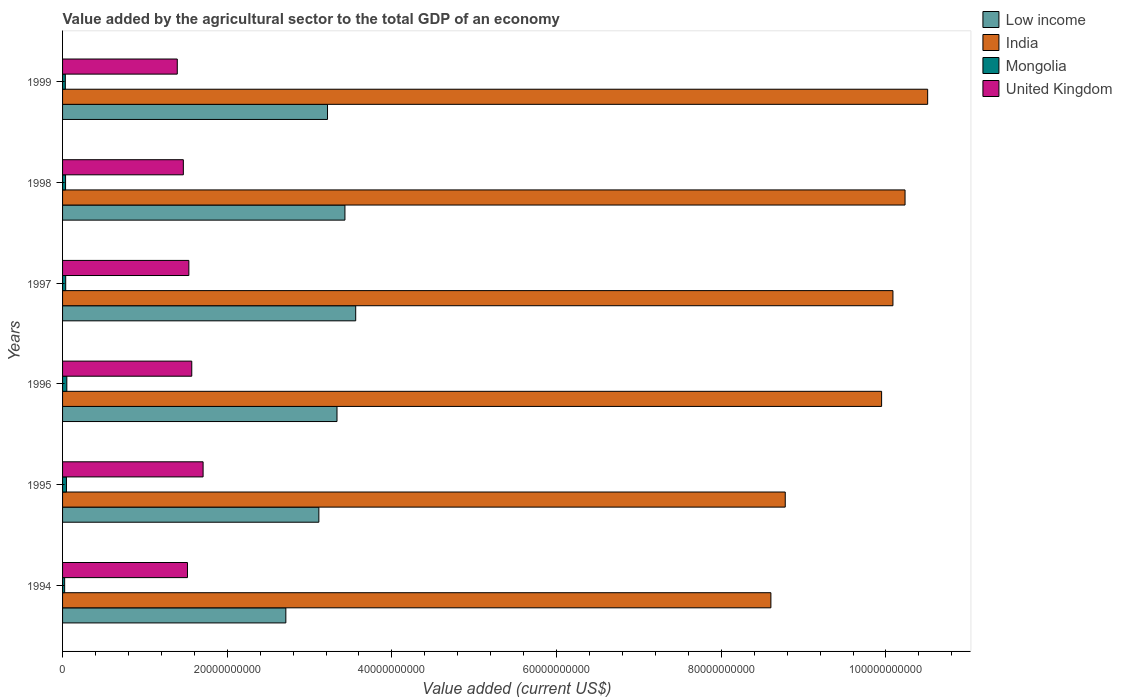How many groups of bars are there?
Your response must be concise. 6. Are the number of bars per tick equal to the number of legend labels?
Your response must be concise. Yes. Are the number of bars on each tick of the Y-axis equal?
Provide a short and direct response. Yes. How many bars are there on the 6th tick from the bottom?
Give a very brief answer. 4. In how many cases, is the number of bars for a given year not equal to the number of legend labels?
Offer a very short reply. 0. What is the value added by the agricultural sector to the total GDP in Low income in 1998?
Ensure brevity in your answer.  3.43e+1. Across all years, what is the maximum value added by the agricultural sector to the total GDP in India?
Make the answer very short. 1.05e+11. Across all years, what is the minimum value added by the agricultural sector to the total GDP in United Kingdom?
Provide a succinct answer. 1.39e+1. In which year was the value added by the agricultural sector to the total GDP in Low income maximum?
Keep it short and to the point. 1997. In which year was the value added by the agricultural sector to the total GDP in United Kingdom minimum?
Offer a terse response. 1999. What is the total value added by the agricultural sector to the total GDP in United Kingdom in the graph?
Provide a succinct answer. 9.19e+1. What is the difference between the value added by the agricultural sector to the total GDP in United Kingdom in 1995 and that in 1999?
Give a very brief answer. 3.13e+09. What is the difference between the value added by the agricultural sector to the total GDP in Mongolia in 1994 and the value added by the agricultural sector to the total GDP in United Kingdom in 1999?
Provide a short and direct response. -1.37e+1. What is the average value added by the agricultural sector to the total GDP in United Kingdom per year?
Make the answer very short. 1.53e+1. In the year 1999, what is the difference between the value added by the agricultural sector to the total GDP in Low income and value added by the agricultural sector to the total GDP in Mongolia?
Your answer should be very brief. 3.18e+1. In how many years, is the value added by the agricultural sector to the total GDP in Low income greater than 40000000000 US$?
Give a very brief answer. 0. What is the ratio of the value added by the agricultural sector to the total GDP in United Kingdom in 1998 to that in 1999?
Make the answer very short. 1.05. Is the difference between the value added by the agricultural sector to the total GDP in Low income in 1995 and 1996 greater than the difference between the value added by the agricultural sector to the total GDP in Mongolia in 1995 and 1996?
Keep it short and to the point. No. What is the difference between the highest and the second highest value added by the agricultural sector to the total GDP in Low income?
Offer a very short reply. 1.31e+09. What is the difference between the highest and the lowest value added by the agricultural sector to the total GDP in Mongolia?
Keep it short and to the point. 2.63e+08. In how many years, is the value added by the agricultural sector to the total GDP in United Kingdom greater than the average value added by the agricultural sector to the total GDP in United Kingdom taken over all years?
Provide a short and direct response. 3. Is the sum of the value added by the agricultural sector to the total GDP in Mongolia in 1994 and 1996 greater than the maximum value added by the agricultural sector to the total GDP in India across all years?
Your answer should be very brief. No. Is it the case that in every year, the sum of the value added by the agricultural sector to the total GDP in Mongolia and value added by the agricultural sector to the total GDP in Low income is greater than the sum of value added by the agricultural sector to the total GDP in India and value added by the agricultural sector to the total GDP in United Kingdom?
Your answer should be compact. Yes. Are all the bars in the graph horizontal?
Offer a terse response. Yes. How many years are there in the graph?
Your answer should be very brief. 6. Are the values on the major ticks of X-axis written in scientific E-notation?
Keep it short and to the point. No. Does the graph contain grids?
Your answer should be compact. No. What is the title of the graph?
Your answer should be very brief. Value added by the agricultural sector to the total GDP of an economy. What is the label or title of the X-axis?
Keep it short and to the point. Value added (current US$). What is the Value added (current US$) in Low income in 1994?
Your response must be concise. 2.71e+1. What is the Value added (current US$) in India in 1994?
Your answer should be compact. 8.60e+1. What is the Value added (current US$) in Mongolia in 1994?
Make the answer very short. 2.54e+08. What is the Value added (current US$) of United Kingdom in 1994?
Your answer should be compact. 1.52e+1. What is the Value added (current US$) of Low income in 1995?
Ensure brevity in your answer.  3.11e+1. What is the Value added (current US$) of India in 1995?
Offer a very short reply. 8.78e+1. What is the Value added (current US$) of Mongolia in 1995?
Ensure brevity in your answer.  4.73e+08. What is the Value added (current US$) of United Kingdom in 1995?
Keep it short and to the point. 1.71e+1. What is the Value added (current US$) of Low income in 1996?
Keep it short and to the point. 3.33e+1. What is the Value added (current US$) of India in 1996?
Offer a terse response. 9.95e+1. What is the Value added (current US$) of Mongolia in 1996?
Give a very brief answer. 5.18e+08. What is the Value added (current US$) in United Kingdom in 1996?
Keep it short and to the point. 1.57e+1. What is the Value added (current US$) in Low income in 1997?
Offer a very short reply. 3.56e+1. What is the Value added (current US$) of India in 1997?
Provide a short and direct response. 1.01e+11. What is the Value added (current US$) in Mongolia in 1997?
Offer a terse response. 3.81e+08. What is the Value added (current US$) of United Kingdom in 1997?
Provide a succinct answer. 1.53e+1. What is the Value added (current US$) of Low income in 1998?
Provide a short and direct response. 3.43e+1. What is the Value added (current US$) in India in 1998?
Give a very brief answer. 1.02e+11. What is the Value added (current US$) of Mongolia in 1998?
Keep it short and to the point. 3.65e+08. What is the Value added (current US$) in United Kingdom in 1998?
Keep it short and to the point. 1.47e+1. What is the Value added (current US$) in Low income in 1999?
Your response must be concise. 3.22e+1. What is the Value added (current US$) of India in 1999?
Provide a succinct answer. 1.05e+11. What is the Value added (current US$) in Mongolia in 1999?
Keep it short and to the point. 3.35e+08. What is the Value added (current US$) of United Kingdom in 1999?
Provide a short and direct response. 1.39e+1. Across all years, what is the maximum Value added (current US$) of Low income?
Ensure brevity in your answer.  3.56e+1. Across all years, what is the maximum Value added (current US$) of India?
Your answer should be very brief. 1.05e+11. Across all years, what is the maximum Value added (current US$) of Mongolia?
Make the answer very short. 5.18e+08. Across all years, what is the maximum Value added (current US$) of United Kingdom?
Make the answer very short. 1.71e+1. Across all years, what is the minimum Value added (current US$) of Low income?
Your answer should be compact. 2.71e+1. Across all years, what is the minimum Value added (current US$) of India?
Your response must be concise. 8.60e+1. Across all years, what is the minimum Value added (current US$) in Mongolia?
Your answer should be compact. 2.54e+08. Across all years, what is the minimum Value added (current US$) in United Kingdom?
Provide a succinct answer. 1.39e+1. What is the total Value added (current US$) in Low income in the graph?
Offer a very short reply. 1.94e+11. What is the total Value added (current US$) of India in the graph?
Offer a very short reply. 5.82e+11. What is the total Value added (current US$) in Mongolia in the graph?
Provide a succinct answer. 2.33e+09. What is the total Value added (current US$) in United Kingdom in the graph?
Ensure brevity in your answer.  9.19e+1. What is the difference between the Value added (current US$) in Low income in 1994 and that in 1995?
Your answer should be compact. -4.01e+09. What is the difference between the Value added (current US$) of India in 1994 and that in 1995?
Give a very brief answer. -1.74e+09. What is the difference between the Value added (current US$) of Mongolia in 1994 and that in 1995?
Make the answer very short. -2.18e+08. What is the difference between the Value added (current US$) of United Kingdom in 1994 and that in 1995?
Offer a terse response. -1.90e+09. What is the difference between the Value added (current US$) of Low income in 1994 and that in 1996?
Provide a short and direct response. -6.21e+09. What is the difference between the Value added (current US$) of India in 1994 and that in 1996?
Offer a terse response. -1.34e+1. What is the difference between the Value added (current US$) in Mongolia in 1994 and that in 1996?
Provide a succinct answer. -2.63e+08. What is the difference between the Value added (current US$) of United Kingdom in 1994 and that in 1996?
Offer a very short reply. -5.22e+08. What is the difference between the Value added (current US$) in Low income in 1994 and that in 1997?
Provide a succinct answer. -8.48e+09. What is the difference between the Value added (current US$) in India in 1994 and that in 1997?
Make the answer very short. -1.48e+1. What is the difference between the Value added (current US$) of Mongolia in 1994 and that in 1997?
Your response must be concise. -1.26e+08. What is the difference between the Value added (current US$) of United Kingdom in 1994 and that in 1997?
Provide a short and direct response. -1.70e+08. What is the difference between the Value added (current US$) in Low income in 1994 and that in 1998?
Offer a very short reply. -7.18e+09. What is the difference between the Value added (current US$) in India in 1994 and that in 1998?
Provide a short and direct response. -1.63e+1. What is the difference between the Value added (current US$) in Mongolia in 1994 and that in 1998?
Provide a short and direct response. -1.10e+08. What is the difference between the Value added (current US$) in United Kingdom in 1994 and that in 1998?
Offer a very short reply. 5.00e+08. What is the difference between the Value added (current US$) in Low income in 1994 and that in 1999?
Ensure brevity in your answer.  -5.06e+09. What is the difference between the Value added (current US$) in India in 1994 and that in 1999?
Ensure brevity in your answer.  -1.90e+1. What is the difference between the Value added (current US$) in Mongolia in 1994 and that in 1999?
Your answer should be very brief. -8.07e+07. What is the difference between the Value added (current US$) in United Kingdom in 1994 and that in 1999?
Offer a terse response. 1.24e+09. What is the difference between the Value added (current US$) in Low income in 1995 and that in 1996?
Provide a succinct answer. -2.20e+09. What is the difference between the Value added (current US$) of India in 1995 and that in 1996?
Ensure brevity in your answer.  -1.17e+1. What is the difference between the Value added (current US$) of Mongolia in 1995 and that in 1996?
Provide a short and direct response. -4.52e+07. What is the difference between the Value added (current US$) of United Kingdom in 1995 and that in 1996?
Keep it short and to the point. 1.38e+09. What is the difference between the Value added (current US$) of Low income in 1995 and that in 1997?
Ensure brevity in your answer.  -4.48e+09. What is the difference between the Value added (current US$) in India in 1995 and that in 1997?
Keep it short and to the point. -1.31e+1. What is the difference between the Value added (current US$) in Mongolia in 1995 and that in 1997?
Provide a succinct answer. 9.19e+07. What is the difference between the Value added (current US$) of United Kingdom in 1995 and that in 1997?
Offer a terse response. 1.73e+09. What is the difference between the Value added (current US$) in Low income in 1995 and that in 1998?
Offer a very short reply. -3.17e+09. What is the difference between the Value added (current US$) of India in 1995 and that in 1998?
Provide a succinct answer. -1.46e+1. What is the difference between the Value added (current US$) in Mongolia in 1995 and that in 1998?
Provide a succinct answer. 1.08e+08. What is the difference between the Value added (current US$) of United Kingdom in 1995 and that in 1998?
Make the answer very short. 2.40e+09. What is the difference between the Value added (current US$) in Low income in 1995 and that in 1999?
Give a very brief answer. -1.05e+09. What is the difference between the Value added (current US$) in India in 1995 and that in 1999?
Ensure brevity in your answer.  -1.73e+1. What is the difference between the Value added (current US$) of Mongolia in 1995 and that in 1999?
Offer a very short reply. 1.37e+08. What is the difference between the Value added (current US$) of United Kingdom in 1995 and that in 1999?
Offer a terse response. 3.13e+09. What is the difference between the Value added (current US$) in Low income in 1996 and that in 1997?
Your response must be concise. -2.27e+09. What is the difference between the Value added (current US$) in India in 1996 and that in 1997?
Offer a very short reply. -1.38e+09. What is the difference between the Value added (current US$) in Mongolia in 1996 and that in 1997?
Provide a succinct answer. 1.37e+08. What is the difference between the Value added (current US$) of United Kingdom in 1996 and that in 1997?
Give a very brief answer. 3.52e+08. What is the difference between the Value added (current US$) in Low income in 1996 and that in 1998?
Your answer should be very brief. -9.64e+08. What is the difference between the Value added (current US$) of India in 1996 and that in 1998?
Provide a short and direct response. -2.85e+09. What is the difference between the Value added (current US$) in Mongolia in 1996 and that in 1998?
Ensure brevity in your answer.  1.53e+08. What is the difference between the Value added (current US$) in United Kingdom in 1996 and that in 1998?
Your answer should be very brief. 1.02e+09. What is the difference between the Value added (current US$) in Low income in 1996 and that in 1999?
Make the answer very short. 1.15e+09. What is the difference between the Value added (current US$) in India in 1996 and that in 1999?
Ensure brevity in your answer.  -5.59e+09. What is the difference between the Value added (current US$) of Mongolia in 1996 and that in 1999?
Ensure brevity in your answer.  1.83e+08. What is the difference between the Value added (current US$) of United Kingdom in 1996 and that in 1999?
Keep it short and to the point. 1.76e+09. What is the difference between the Value added (current US$) in Low income in 1997 and that in 1998?
Your answer should be compact. 1.31e+09. What is the difference between the Value added (current US$) of India in 1997 and that in 1998?
Give a very brief answer. -1.47e+09. What is the difference between the Value added (current US$) of Mongolia in 1997 and that in 1998?
Ensure brevity in your answer.  1.60e+07. What is the difference between the Value added (current US$) of United Kingdom in 1997 and that in 1998?
Provide a short and direct response. 6.70e+08. What is the difference between the Value added (current US$) of Low income in 1997 and that in 1999?
Offer a terse response. 3.42e+09. What is the difference between the Value added (current US$) of India in 1997 and that in 1999?
Provide a succinct answer. -4.22e+09. What is the difference between the Value added (current US$) in Mongolia in 1997 and that in 1999?
Ensure brevity in your answer.  4.55e+07. What is the difference between the Value added (current US$) of United Kingdom in 1997 and that in 1999?
Give a very brief answer. 1.41e+09. What is the difference between the Value added (current US$) of Low income in 1998 and that in 1999?
Your response must be concise. 2.12e+09. What is the difference between the Value added (current US$) of India in 1998 and that in 1999?
Make the answer very short. -2.75e+09. What is the difference between the Value added (current US$) in Mongolia in 1998 and that in 1999?
Give a very brief answer. 2.95e+07. What is the difference between the Value added (current US$) of United Kingdom in 1998 and that in 1999?
Give a very brief answer. 7.36e+08. What is the difference between the Value added (current US$) in Low income in 1994 and the Value added (current US$) in India in 1995?
Make the answer very short. -6.07e+1. What is the difference between the Value added (current US$) in Low income in 1994 and the Value added (current US$) in Mongolia in 1995?
Offer a very short reply. 2.66e+1. What is the difference between the Value added (current US$) in Low income in 1994 and the Value added (current US$) in United Kingdom in 1995?
Offer a terse response. 1.01e+1. What is the difference between the Value added (current US$) of India in 1994 and the Value added (current US$) of Mongolia in 1995?
Your answer should be compact. 8.56e+1. What is the difference between the Value added (current US$) in India in 1994 and the Value added (current US$) in United Kingdom in 1995?
Your response must be concise. 6.90e+1. What is the difference between the Value added (current US$) in Mongolia in 1994 and the Value added (current US$) in United Kingdom in 1995?
Your answer should be compact. -1.68e+1. What is the difference between the Value added (current US$) of Low income in 1994 and the Value added (current US$) of India in 1996?
Keep it short and to the point. -7.24e+1. What is the difference between the Value added (current US$) of Low income in 1994 and the Value added (current US$) of Mongolia in 1996?
Make the answer very short. 2.66e+1. What is the difference between the Value added (current US$) of Low income in 1994 and the Value added (current US$) of United Kingdom in 1996?
Give a very brief answer. 1.14e+1. What is the difference between the Value added (current US$) of India in 1994 and the Value added (current US$) of Mongolia in 1996?
Your answer should be compact. 8.55e+1. What is the difference between the Value added (current US$) of India in 1994 and the Value added (current US$) of United Kingdom in 1996?
Ensure brevity in your answer.  7.03e+1. What is the difference between the Value added (current US$) in Mongolia in 1994 and the Value added (current US$) in United Kingdom in 1996?
Provide a succinct answer. -1.54e+1. What is the difference between the Value added (current US$) in Low income in 1994 and the Value added (current US$) in India in 1997?
Keep it short and to the point. -7.37e+1. What is the difference between the Value added (current US$) in Low income in 1994 and the Value added (current US$) in Mongolia in 1997?
Your answer should be compact. 2.67e+1. What is the difference between the Value added (current US$) in Low income in 1994 and the Value added (current US$) in United Kingdom in 1997?
Your answer should be compact. 1.18e+1. What is the difference between the Value added (current US$) in India in 1994 and the Value added (current US$) in Mongolia in 1997?
Make the answer very short. 8.56e+1. What is the difference between the Value added (current US$) of India in 1994 and the Value added (current US$) of United Kingdom in 1997?
Ensure brevity in your answer.  7.07e+1. What is the difference between the Value added (current US$) of Mongolia in 1994 and the Value added (current US$) of United Kingdom in 1997?
Your answer should be compact. -1.51e+1. What is the difference between the Value added (current US$) in Low income in 1994 and the Value added (current US$) in India in 1998?
Provide a short and direct response. -7.52e+1. What is the difference between the Value added (current US$) in Low income in 1994 and the Value added (current US$) in Mongolia in 1998?
Offer a terse response. 2.68e+1. What is the difference between the Value added (current US$) in Low income in 1994 and the Value added (current US$) in United Kingdom in 1998?
Your answer should be very brief. 1.24e+1. What is the difference between the Value added (current US$) of India in 1994 and the Value added (current US$) of Mongolia in 1998?
Ensure brevity in your answer.  8.57e+1. What is the difference between the Value added (current US$) in India in 1994 and the Value added (current US$) in United Kingdom in 1998?
Provide a short and direct response. 7.14e+1. What is the difference between the Value added (current US$) in Mongolia in 1994 and the Value added (current US$) in United Kingdom in 1998?
Your answer should be compact. -1.44e+1. What is the difference between the Value added (current US$) of Low income in 1994 and the Value added (current US$) of India in 1999?
Your answer should be very brief. -7.79e+1. What is the difference between the Value added (current US$) of Low income in 1994 and the Value added (current US$) of Mongolia in 1999?
Offer a very short reply. 2.68e+1. What is the difference between the Value added (current US$) of Low income in 1994 and the Value added (current US$) of United Kingdom in 1999?
Your answer should be compact. 1.32e+1. What is the difference between the Value added (current US$) of India in 1994 and the Value added (current US$) of Mongolia in 1999?
Give a very brief answer. 8.57e+1. What is the difference between the Value added (current US$) of India in 1994 and the Value added (current US$) of United Kingdom in 1999?
Provide a succinct answer. 7.21e+1. What is the difference between the Value added (current US$) in Mongolia in 1994 and the Value added (current US$) in United Kingdom in 1999?
Give a very brief answer. -1.37e+1. What is the difference between the Value added (current US$) of Low income in 1995 and the Value added (current US$) of India in 1996?
Give a very brief answer. -6.83e+1. What is the difference between the Value added (current US$) in Low income in 1995 and the Value added (current US$) in Mongolia in 1996?
Your response must be concise. 3.06e+1. What is the difference between the Value added (current US$) of Low income in 1995 and the Value added (current US$) of United Kingdom in 1996?
Provide a short and direct response. 1.54e+1. What is the difference between the Value added (current US$) of India in 1995 and the Value added (current US$) of Mongolia in 1996?
Make the answer very short. 8.73e+1. What is the difference between the Value added (current US$) of India in 1995 and the Value added (current US$) of United Kingdom in 1996?
Ensure brevity in your answer.  7.21e+1. What is the difference between the Value added (current US$) in Mongolia in 1995 and the Value added (current US$) in United Kingdom in 1996?
Ensure brevity in your answer.  -1.52e+1. What is the difference between the Value added (current US$) in Low income in 1995 and the Value added (current US$) in India in 1997?
Make the answer very short. -6.97e+1. What is the difference between the Value added (current US$) of Low income in 1995 and the Value added (current US$) of Mongolia in 1997?
Provide a succinct answer. 3.07e+1. What is the difference between the Value added (current US$) of Low income in 1995 and the Value added (current US$) of United Kingdom in 1997?
Keep it short and to the point. 1.58e+1. What is the difference between the Value added (current US$) in India in 1995 and the Value added (current US$) in Mongolia in 1997?
Offer a terse response. 8.74e+1. What is the difference between the Value added (current US$) in India in 1995 and the Value added (current US$) in United Kingdom in 1997?
Provide a short and direct response. 7.24e+1. What is the difference between the Value added (current US$) of Mongolia in 1995 and the Value added (current US$) of United Kingdom in 1997?
Provide a short and direct response. -1.49e+1. What is the difference between the Value added (current US$) of Low income in 1995 and the Value added (current US$) of India in 1998?
Your response must be concise. -7.12e+1. What is the difference between the Value added (current US$) in Low income in 1995 and the Value added (current US$) in Mongolia in 1998?
Give a very brief answer. 3.08e+1. What is the difference between the Value added (current US$) of Low income in 1995 and the Value added (current US$) of United Kingdom in 1998?
Offer a very short reply. 1.65e+1. What is the difference between the Value added (current US$) in India in 1995 and the Value added (current US$) in Mongolia in 1998?
Give a very brief answer. 8.74e+1. What is the difference between the Value added (current US$) of India in 1995 and the Value added (current US$) of United Kingdom in 1998?
Provide a succinct answer. 7.31e+1. What is the difference between the Value added (current US$) in Mongolia in 1995 and the Value added (current US$) in United Kingdom in 1998?
Ensure brevity in your answer.  -1.42e+1. What is the difference between the Value added (current US$) in Low income in 1995 and the Value added (current US$) in India in 1999?
Make the answer very short. -7.39e+1. What is the difference between the Value added (current US$) in Low income in 1995 and the Value added (current US$) in Mongolia in 1999?
Offer a very short reply. 3.08e+1. What is the difference between the Value added (current US$) in Low income in 1995 and the Value added (current US$) in United Kingdom in 1999?
Keep it short and to the point. 1.72e+1. What is the difference between the Value added (current US$) in India in 1995 and the Value added (current US$) in Mongolia in 1999?
Offer a terse response. 8.74e+1. What is the difference between the Value added (current US$) in India in 1995 and the Value added (current US$) in United Kingdom in 1999?
Provide a succinct answer. 7.38e+1. What is the difference between the Value added (current US$) in Mongolia in 1995 and the Value added (current US$) in United Kingdom in 1999?
Make the answer very short. -1.35e+1. What is the difference between the Value added (current US$) in Low income in 1996 and the Value added (current US$) in India in 1997?
Make the answer very short. -6.75e+1. What is the difference between the Value added (current US$) of Low income in 1996 and the Value added (current US$) of Mongolia in 1997?
Ensure brevity in your answer.  3.30e+1. What is the difference between the Value added (current US$) of Low income in 1996 and the Value added (current US$) of United Kingdom in 1997?
Your answer should be compact. 1.80e+1. What is the difference between the Value added (current US$) in India in 1996 and the Value added (current US$) in Mongolia in 1997?
Give a very brief answer. 9.91e+1. What is the difference between the Value added (current US$) in India in 1996 and the Value added (current US$) in United Kingdom in 1997?
Give a very brief answer. 8.41e+1. What is the difference between the Value added (current US$) in Mongolia in 1996 and the Value added (current US$) in United Kingdom in 1997?
Your answer should be very brief. -1.48e+1. What is the difference between the Value added (current US$) in Low income in 1996 and the Value added (current US$) in India in 1998?
Your answer should be compact. -6.90e+1. What is the difference between the Value added (current US$) of Low income in 1996 and the Value added (current US$) of Mongolia in 1998?
Keep it short and to the point. 3.30e+1. What is the difference between the Value added (current US$) of Low income in 1996 and the Value added (current US$) of United Kingdom in 1998?
Ensure brevity in your answer.  1.87e+1. What is the difference between the Value added (current US$) of India in 1996 and the Value added (current US$) of Mongolia in 1998?
Your answer should be compact. 9.91e+1. What is the difference between the Value added (current US$) of India in 1996 and the Value added (current US$) of United Kingdom in 1998?
Your answer should be very brief. 8.48e+1. What is the difference between the Value added (current US$) of Mongolia in 1996 and the Value added (current US$) of United Kingdom in 1998?
Your answer should be compact. -1.42e+1. What is the difference between the Value added (current US$) of Low income in 1996 and the Value added (current US$) of India in 1999?
Provide a succinct answer. -7.17e+1. What is the difference between the Value added (current US$) in Low income in 1996 and the Value added (current US$) in Mongolia in 1999?
Provide a succinct answer. 3.30e+1. What is the difference between the Value added (current US$) of Low income in 1996 and the Value added (current US$) of United Kingdom in 1999?
Provide a short and direct response. 1.94e+1. What is the difference between the Value added (current US$) of India in 1996 and the Value added (current US$) of Mongolia in 1999?
Your response must be concise. 9.91e+1. What is the difference between the Value added (current US$) in India in 1996 and the Value added (current US$) in United Kingdom in 1999?
Offer a very short reply. 8.55e+1. What is the difference between the Value added (current US$) of Mongolia in 1996 and the Value added (current US$) of United Kingdom in 1999?
Provide a short and direct response. -1.34e+1. What is the difference between the Value added (current US$) in Low income in 1997 and the Value added (current US$) in India in 1998?
Offer a terse response. -6.67e+1. What is the difference between the Value added (current US$) in Low income in 1997 and the Value added (current US$) in Mongolia in 1998?
Offer a very short reply. 3.52e+1. What is the difference between the Value added (current US$) of Low income in 1997 and the Value added (current US$) of United Kingdom in 1998?
Your answer should be compact. 2.09e+1. What is the difference between the Value added (current US$) of India in 1997 and the Value added (current US$) of Mongolia in 1998?
Make the answer very short. 1.00e+11. What is the difference between the Value added (current US$) of India in 1997 and the Value added (current US$) of United Kingdom in 1998?
Your response must be concise. 8.62e+1. What is the difference between the Value added (current US$) of Mongolia in 1997 and the Value added (current US$) of United Kingdom in 1998?
Your answer should be compact. -1.43e+1. What is the difference between the Value added (current US$) of Low income in 1997 and the Value added (current US$) of India in 1999?
Your response must be concise. -6.95e+1. What is the difference between the Value added (current US$) of Low income in 1997 and the Value added (current US$) of Mongolia in 1999?
Provide a short and direct response. 3.53e+1. What is the difference between the Value added (current US$) of Low income in 1997 and the Value added (current US$) of United Kingdom in 1999?
Give a very brief answer. 2.17e+1. What is the difference between the Value added (current US$) in India in 1997 and the Value added (current US$) in Mongolia in 1999?
Give a very brief answer. 1.01e+11. What is the difference between the Value added (current US$) in India in 1997 and the Value added (current US$) in United Kingdom in 1999?
Provide a short and direct response. 8.69e+1. What is the difference between the Value added (current US$) in Mongolia in 1997 and the Value added (current US$) in United Kingdom in 1999?
Provide a short and direct response. -1.36e+1. What is the difference between the Value added (current US$) of Low income in 1998 and the Value added (current US$) of India in 1999?
Keep it short and to the point. -7.08e+1. What is the difference between the Value added (current US$) of Low income in 1998 and the Value added (current US$) of Mongolia in 1999?
Your answer should be compact. 3.40e+1. What is the difference between the Value added (current US$) in Low income in 1998 and the Value added (current US$) in United Kingdom in 1999?
Provide a succinct answer. 2.04e+1. What is the difference between the Value added (current US$) of India in 1998 and the Value added (current US$) of Mongolia in 1999?
Give a very brief answer. 1.02e+11. What is the difference between the Value added (current US$) in India in 1998 and the Value added (current US$) in United Kingdom in 1999?
Your answer should be very brief. 8.84e+1. What is the difference between the Value added (current US$) of Mongolia in 1998 and the Value added (current US$) of United Kingdom in 1999?
Make the answer very short. -1.36e+1. What is the average Value added (current US$) of Low income per year?
Your answer should be compact. 3.23e+1. What is the average Value added (current US$) of India per year?
Ensure brevity in your answer.  9.69e+1. What is the average Value added (current US$) in Mongolia per year?
Provide a short and direct response. 3.88e+08. What is the average Value added (current US$) in United Kingdom per year?
Offer a very short reply. 1.53e+1. In the year 1994, what is the difference between the Value added (current US$) of Low income and Value added (current US$) of India?
Keep it short and to the point. -5.89e+1. In the year 1994, what is the difference between the Value added (current US$) in Low income and Value added (current US$) in Mongolia?
Your answer should be very brief. 2.69e+1. In the year 1994, what is the difference between the Value added (current US$) of Low income and Value added (current US$) of United Kingdom?
Keep it short and to the point. 1.19e+1. In the year 1994, what is the difference between the Value added (current US$) in India and Value added (current US$) in Mongolia?
Your response must be concise. 8.58e+1. In the year 1994, what is the difference between the Value added (current US$) of India and Value added (current US$) of United Kingdom?
Your answer should be compact. 7.09e+1. In the year 1994, what is the difference between the Value added (current US$) in Mongolia and Value added (current US$) in United Kingdom?
Ensure brevity in your answer.  -1.49e+1. In the year 1995, what is the difference between the Value added (current US$) of Low income and Value added (current US$) of India?
Ensure brevity in your answer.  -5.66e+1. In the year 1995, what is the difference between the Value added (current US$) in Low income and Value added (current US$) in Mongolia?
Your answer should be compact. 3.07e+1. In the year 1995, what is the difference between the Value added (current US$) of Low income and Value added (current US$) of United Kingdom?
Offer a very short reply. 1.41e+1. In the year 1995, what is the difference between the Value added (current US$) of India and Value added (current US$) of Mongolia?
Your answer should be very brief. 8.73e+1. In the year 1995, what is the difference between the Value added (current US$) in India and Value added (current US$) in United Kingdom?
Your answer should be compact. 7.07e+1. In the year 1995, what is the difference between the Value added (current US$) in Mongolia and Value added (current US$) in United Kingdom?
Provide a succinct answer. -1.66e+1. In the year 1996, what is the difference between the Value added (current US$) in Low income and Value added (current US$) in India?
Keep it short and to the point. -6.61e+1. In the year 1996, what is the difference between the Value added (current US$) of Low income and Value added (current US$) of Mongolia?
Your answer should be very brief. 3.28e+1. In the year 1996, what is the difference between the Value added (current US$) in Low income and Value added (current US$) in United Kingdom?
Provide a short and direct response. 1.76e+1. In the year 1996, what is the difference between the Value added (current US$) in India and Value added (current US$) in Mongolia?
Your answer should be very brief. 9.90e+1. In the year 1996, what is the difference between the Value added (current US$) of India and Value added (current US$) of United Kingdom?
Offer a terse response. 8.38e+1. In the year 1996, what is the difference between the Value added (current US$) of Mongolia and Value added (current US$) of United Kingdom?
Your answer should be compact. -1.52e+1. In the year 1997, what is the difference between the Value added (current US$) in Low income and Value added (current US$) in India?
Keep it short and to the point. -6.52e+1. In the year 1997, what is the difference between the Value added (current US$) in Low income and Value added (current US$) in Mongolia?
Make the answer very short. 3.52e+1. In the year 1997, what is the difference between the Value added (current US$) of Low income and Value added (current US$) of United Kingdom?
Provide a succinct answer. 2.03e+1. In the year 1997, what is the difference between the Value added (current US$) of India and Value added (current US$) of Mongolia?
Your response must be concise. 1.00e+11. In the year 1997, what is the difference between the Value added (current US$) of India and Value added (current US$) of United Kingdom?
Offer a terse response. 8.55e+1. In the year 1997, what is the difference between the Value added (current US$) in Mongolia and Value added (current US$) in United Kingdom?
Offer a terse response. -1.50e+1. In the year 1998, what is the difference between the Value added (current US$) in Low income and Value added (current US$) in India?
Your answer should be very brief. -6.80e+1. In the year 1998, what is the difference between the Value added (current US$) in Low income and Value added (current US$) in Mongolia?
Provide a succinct answer. 3.39e+1. In the year 1998, what is the difference between the Value added (current US$) of Low income and Value added (current US$) of United Kingdom?
Offer a terse response. 1.96e+1. In the year 1998, what is the difference between the Value added (current US$) of India and Value added (current US$) of Mongolia?
Your response must be concise. 1.02e+11. In the year 1998, what is the difference between the Value added (current US$) of India and Value added (current US$) of United Kingdom?
Your answer should be very brief. 8.77e+1. In the year 1998, what is the difference between the Value added (current US$) in Mongolia and Value added (current US$) in United Kingdom?
Keep it short and to the point. -1.43e+1. In the year 1999, what is the difference between the Value added (current US$) in Low income and Value added (current US$) in India?
Provide a succinct answer. -7.29e+1. In the year 1999, what is the difference between the Value added (current US$) of Low income and Value added (current US$) of Mongolia?
Give a very brief answer. 3.18e+1. In the year 1999, what is the difference between the Value added (current US$) of Low income and Value added (current US$) of United Kingdom?
Offer a terse response. 1.82e+1. In the year 1999, what is the difference between the Value added (current US$) in India and Value added (current US$) in Mongolia?
Your response must be concise. 1.05e+11. In the year 1999, what is the difference between the Value added (current US$) in India and Value added (current US$) in United Kingdom?
Provide a succinct answer. 9.11e+1. In the year 1999, what is the difference between the Value added (current US$) in Mongolia and Value added (current US$) in United Kingdom?
Your answer should be very brief. -1.36e+1. What is the ratio of the Value added (current US$) of Low income in 1994 to that in 1995?
Provide a succinct answer. 0.87. What is the ratio of the Value added (current US$) of India in 1994 to that in 1995?
Give a very brief answer. 0.98. What is the ratio of the Value added (current US$) in Mongolia in 1994 to that in 1995?
Offer a very short reply. 0.54. What is the ratio of the Value added (current US$) in United Kingdom in 1994 to that in 1995?
Your answer should be compact. 0.89. What is the ratio of the Value added (current US$) of Low income in 1994 to that in 1996?
Your answer should be compact. 0.81. What is the ratio of the Value added (current US$) in India in 1994 to that in 1996?
Your response must be concise. 0.86. What is the ratio of the Value added (current US$) of Mongolia in 1994 to that in 1996?
Give a very brief answer. 0.49. What is the ratio of the Value added (current US$) in United Kingdom in 1994 to that in 1996?
Give a very brief answer. 0.97. What is the ratio of the Value added (current US$) in Low income in 1994 to that in 1997?
Make the answer very short. 0.76. What is the ratio of the Value added (current US$) in India in 1994 to that in 1997?
Your answer should be very brief. 0.85. What is the ratio of the Value added (current US$) in Mongolia in 1994 to that in 1997?
Your answer should be compact. 0.67. What is the ratio of the Value added (current US$) in United Kingdom in 1994 to that in 1997?
Your response must be concise. 0.99. What is the ratio of the Value added (current US$) in Low income in 1994 to that in 1998?
Make the answer very short. 0.79. What is the ratio of the Value added (current US$) of India in 1994 to that in 1998?
Your response must be concise. 0.84. What is the ratio of the Value added (current US$) of Mongolia in 1994 to that in 1998?
Offer a terse response. 0.7. What is the ratio of the Value added (current US$) in United Kingdom in 1994 to that in 1998?
Keep it short and to the point. 1.03. What is the ratio of the Value added (current US$) in Low income in 1994 to that in 1999?
Your response must be concise. 0.84. What is the ratio of the Value added (current US$) of India in 1994 to that in 1999?
Offer a very short reply. 0.82. What is the ratio of the Value added (current US$) of Mongolia in 1994 to that in 1999?
Your response must be concise. 0.76. What is the ratio of the Value added (current US$) of United Kingdom in 1994 to that in 1999?
Your answer should be compact. 1.09. What is the ratio of the Value added (current US$) of Low income in 1995 to that in 1996?
Make the answer very short. 0.93. What is the ratio of the Value added (current US$) of India in 1995 to that in 1996?
Offer a very short reply. 0.88. What is the ratio of the Value added (current US$) of Mongolia in 1995 to that in 1996?
Your answer should be very brief. 0.91. What is the ratio of the Value added (current US$) of United Kingdom in 1995 to that in 1996?
Offer a very short reply. 1.09. What is the ratio of the Value added (current US$) of Low income in 1995 to that in 1997?
Make the answer very short. 0.87. What is the ratio of the Value added (current US$) of India in 1995 to that in 1997?
Your answer should be very brief. 0.87. What is the ratio of the Value added (current US$) of Mongolia in 1995 to that in 1997?
Your answer should be compact. 1.24. What is the ratio of the Value added (current US$) in United Kingdom in 1995 to that in 1997?
Your answer should be very brief. 1.11. What is the ratio of the Value added (current US$) of Low income in 1995 to that in 1998?
Provide a succinct answer. 0.91. What is the ratio of the Value added (current US$) of India in 1995 to that in 1998?
Your answer should be very brief. 0.86. What is the ratio of the Value added (current US$) in Mongolia in 1995 to that in 1998?
Keep it short and to the point. 1.3. What is the ratio of the Value added (current US$) in United Kingdom in 1995 to that in 1998?
Make the answer very short. 1.16. What is the ratio of the Value added (current US$) in Low income in 1995 to that in 1999?
Provide a short and direct response. 0.97. What is the ratio of the Value added (current US$) in India in 1995 to that in 1999?
Keep it short and to the point. 0.84. What is the ratio of the Value added (current US$) of Mongolia in 1995 to that in 1999?
Offer a terse response. 1.41. What is the ratio of the Value added (current US$) of United Kingdom in 1995 to that in 1999?
Offer a terse response. 1.23. What is the ratio of the Value added (current US$) in Low income in 1996 to that in 1997?
Your answer should be compact. 0.94. What is the ratio of the Value added (current US$) in India in 1996 to that in 1997?
Your answer should be compact. 0.99. What is the ratio of the Value added (current US$) in Mongolia in 1996 to that in 1997?
Offer a terse response. 1.36. What is the ratio of the Value added (current US$) of United Kingdom in 1996 to that in 1997?
Offer a very short reply. 1.02. What is the ratio of the Value added (current US$) of Low income in 1996 to that in 1998?
Provide a succinct answer. 0.97. What is the ratio of the Value added (current US$) of India in 1996 to that in 1998?
Offer a terse response. 0.97. What is the ratio of the Value added (current US$) in Mongolia in 1996 to that in 1998?
Offer a terse response. 1.42. What is the ratio of the Value added (current US$) in United Kingdom in 1996 to that in 1998?
Keep it short and to the point. 1.07. What is the ratio of the Value added (current US$) of Low income in 1996 to that in 1999?
Offer a very short reply. 1.04. What is the ratio of the Value added (current US$) of India in 1996 to that in 1999?
Offer a terse response. 0.95. What is the ratio of the Value added (current US$) in Mongolia in 1996 to that in 1999?
Your answer should be very brief. 1.54. What is the ratio of the Value added (current US$) in United Kingdom in 1996 to that in 1999?
Ensure brevity in your answer.  1.13. What is the ratio of the Value added (current US$) in Low income in 1997 to that in 1998?
Your answer should be very brief. 1.04. What is the ratio of the Value added (current US$) of India in 1997 to that in 1998?
Make the answer very short. 0.99. What is the ratio of the Value added (current US$) of Mongolia in 1997 to that in 1998?
Offer a very short reply. 1.04. What is the ratio of the Value added (current US$) of United Kingdom in 1997 to that in 1998?
Provide a short and direct response. 1.05. What is the ratio of the Value added (current US$) in Low income in 1997 to that in 1999?
Give a very brief answer. 1.11. What is the ratio of the Value added (current US$) of India in 1997 to that in 1999?
Make the answer very short. 0.96. What is the ratio of the Value added (current US$) of Mongolia in 1997 to that in 1999?
Provide a short and direct response. 1.14. What is the ratio of the Value added (current US$) of United Kingdom in 1997 to that in 1999?
Keep it short and to the point. 1.1. What is the ratio of the Value added (current US$) in Low income in 1998 to that in 1999?
Keep it short and to the point. 1.07. What is the ratio of the Value added (current US$) in India in 1998 to that in 1999?
Make the answer very short. 0.97. What is the ratio of the Value added (current US$) of Mongolia in 1998 to that in 1999?
Give a very brief answer. 1.09. What is the ratio of the Value added (current US$) of United Kingdom in 1998 to that in 1999?
Your answer should be compact. 1.05. What is the difference between the highest and the second highest Value added (current US$) in Low income?
Keep it short and to the point. 1.31e+09. What is the difference between the highest and the second highest Value added (current US$) in India?
Ensure brevity in your answer.  2.75e+09. What is the difference between the highest and the second highest Value added (current US$) of Mongolia?
Offer a terse response. 4.52e+07. What is the difference between the highest and the second highest Value added (current US$) of United Kingdom?
Your answer should be compact. 1.38e+09. What is the difference between the highest and the lowest Value added (current US$) of Low income?
Make the answer very short. 8.48e+09. What is the difference between the highest and the lowest Value added (current US$) in India?
Ensure brevity in your answer.  1.90e+1. What is the difference between the highest and the lowest Value added (current US$) in Mongolia?
Offer a very short reply. 2.63e+08. What is the difference between the highest and the lowest Value added (current US$) in United Kingdom?
Provide a short and direct response. 3.13e+09. 